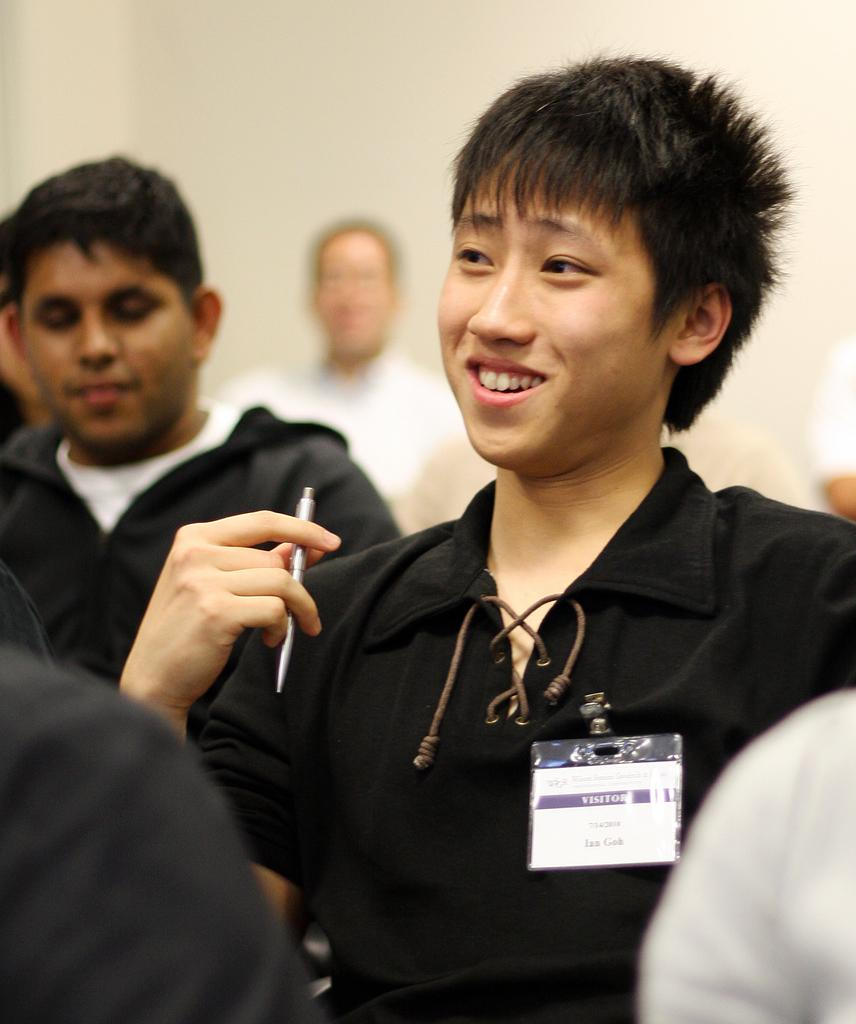What is the color of the wall in the image? There is a white wall in the image. What are the people in the image doing? There are people sitting in the image. Can you describe the person holding an object in the image? There is a person holding an ID card and a pen in the image. How many sacks are visible in the image? There are no sacks present in the image. What type of tank is being used by the people in the image? There is no tank present in the image. 